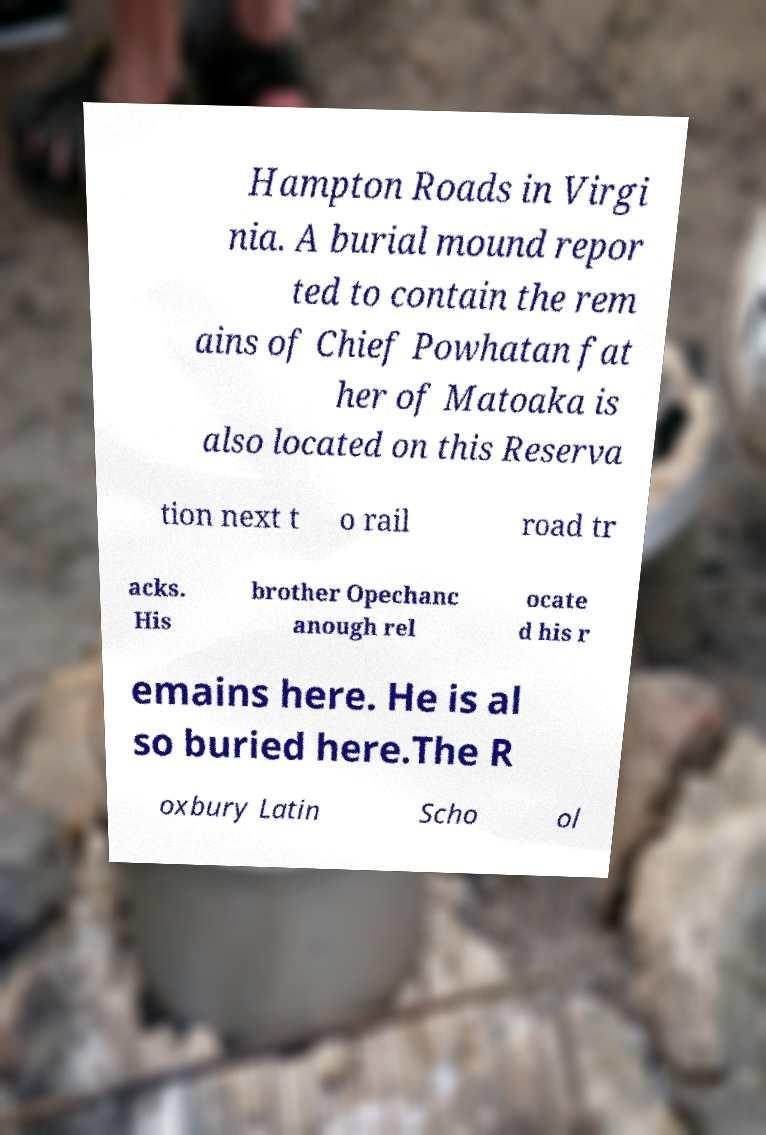Please read and relay the text visible in this image. What does it say? Hampton Roads in Virgi nia. A burial mound repor ted to contain the rem ains of Chief Powhatan fat her of Matoaka is also located on this Reserva tion next t o rail road tr acks. His brother Opechanc anough rel ocate d his r emains here. He is al so buried here.The R oxbury Latin Scho ol 